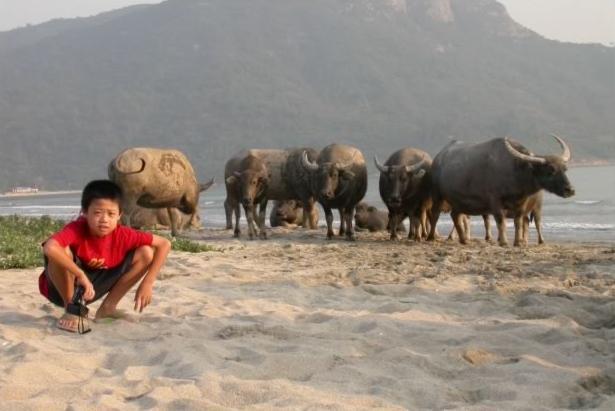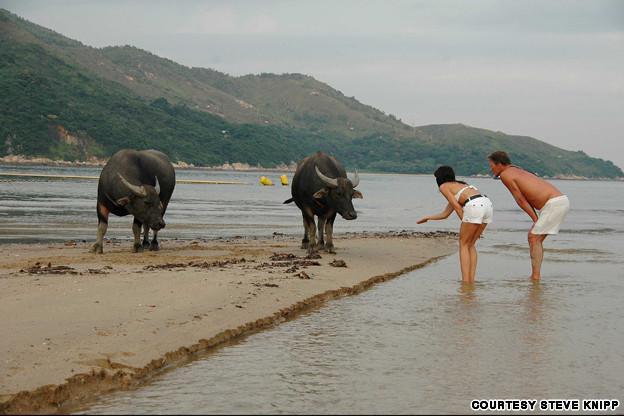The first image is the image on the left, the second image is the image on the right. Analyze the images presented: Is the assertion "There are animals but no humans on both pictures." valid? Answer yes or no. No. The first image is the image on the left, the second image is the image on the right. Analyze the images presented: Is the assertion "An image with reclining water buffalo includes at least one bird, which is not in flight." valid? Answer yes or no. No. 